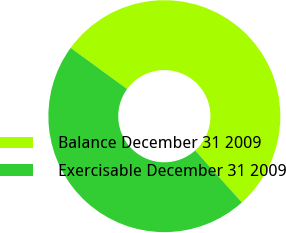Convert chart. <chart><loc_0><loc_0><loc_500><loc_500><pie_chart><fcel>Balance December 31 2009<fcel>Exercisable December 31 2009<nl><fcel>53.33%<fcel>46.67%<nl></chart> 